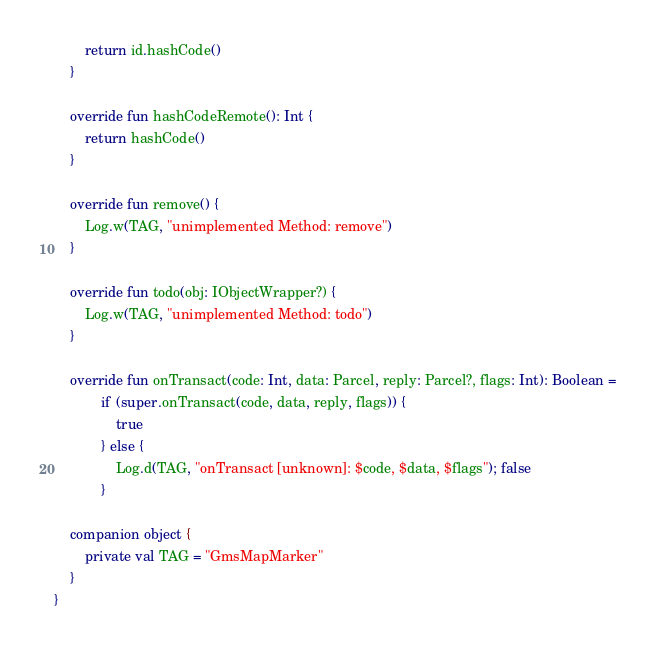Convert code to text. <code><loc_0><loc_0><loc_500><loc_500><_Kotlin_>        return id.hashCode()
    }

    override fun hashCodeRemote(): Int {
        return hashCode()
    }

    override fun remove() {
        Log.w(TAG, "unimplemented Method: remove")
    }

    override fun todo(obj: IObjectWrapper?) {
        Log.w(TAG, "unimplemented Method: todo")
    }

    override fun onTransact(code: Int, data: Parcel, reply: Parcel?, flags: Int): Boolean =
            if (super.onTransact(code, data, reply, flags)) {
                true
            } else {
                Log.d(TAG, "onTransact [unknown]: $code, $data, $flags"); false
            }

    companion object {
        private val TAG = "GmsMapMarker"
    }
}
</code> 